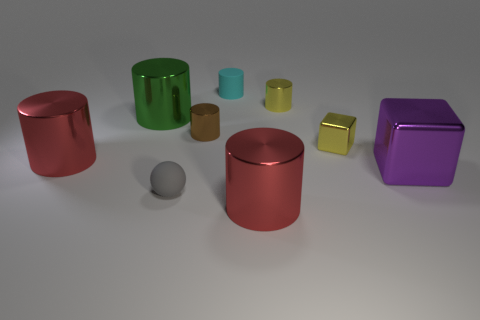Can you describe the lighting and shadows in the scene? The lighting in the scene is diffused and appears to be coming from above as indicated by the soft shadows directly underneath the objects. These shadows are fairly short and soft-edged, suggesting a relatively large and distant light source. 